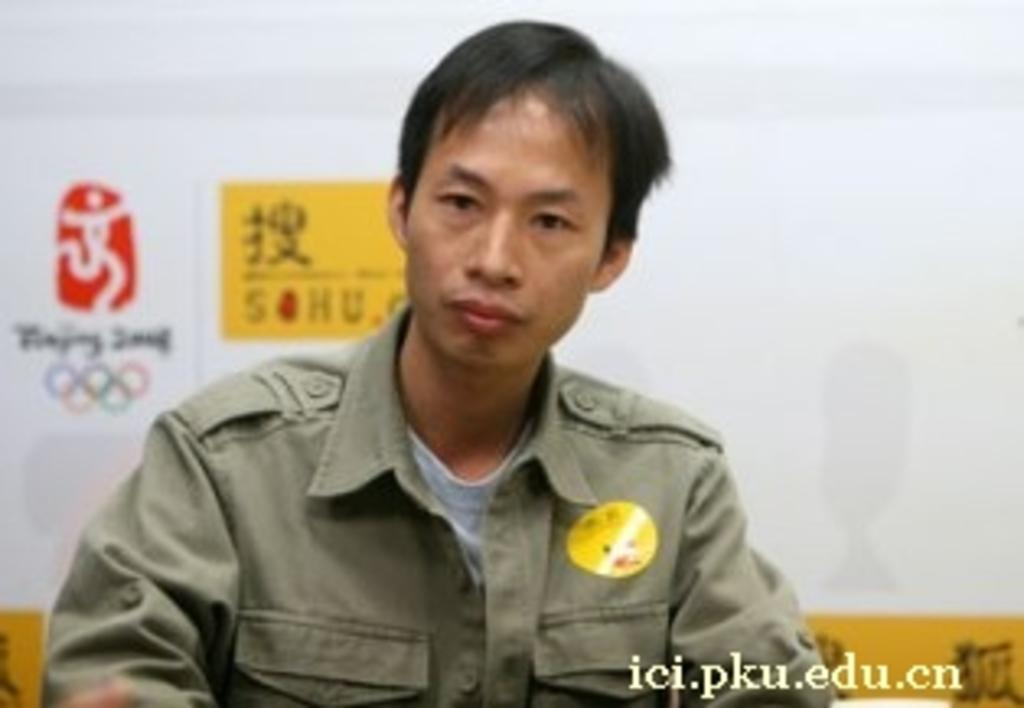What is the position of the person in the image? There is a man seated in the image. What can be seen in the background of the image? There are logos visible in the background of the image. Where is the text located in the image? The text is present at the bottom right corner of the image. What type of beast can be seen roaming in the aftermath of the image? There is no beast or aftermath present in the image; it features a man seated with logos in the background and text at the bottom right corner. 